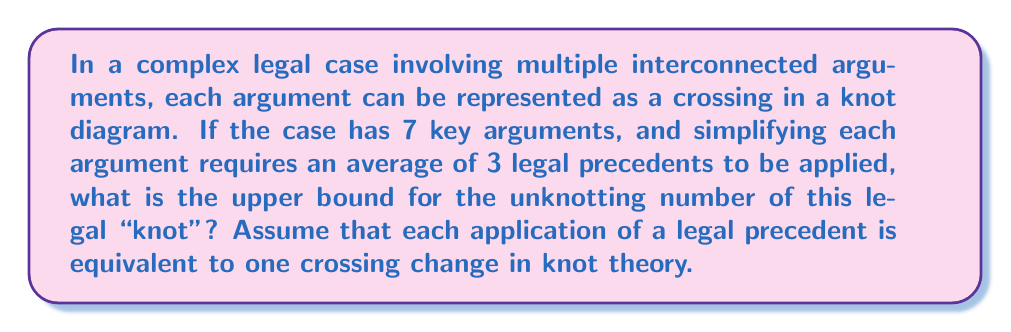Give your solution to this math problem. Let's approach this step-by-step:

1) In knot theory, the unknotting number is the minimum number of crossing changes required to transform a knot into the unknot (a simple loop).

2) In our legal analogy:
   - Each argument is represented by a crossing in the knot diagram.
   - Simplifying an argument is equivalent to changing a crossing.
   - The goal is to simplify all arguments to reach a clear, "unknotted" legal conclusion.

3) We are given:
   - Number of key arguments: 7
   - Average number of legal precedents needed to simplify each argument: 3

4) In the worst-case scenario, we might need to apply all 3 precedents to each argument to simplify it. This gives us an upper bound.

5) To calculate the upper bound:
   $$ \text{Upper bound} = \text{Number of arguments} \times \text{Average precedents per argument} $$
   $$ \text{Upper bound} = 7 \times 3 = 21 $$

6) In knot theory terms, this means our legal "knot" has an unknotting number of at most 21.

It's important to note that this is an upper bound. In practice, some arguments might be simplified with fewer precedents, or simplifying one argument might automatically simplify others, potentially reducing the actual number of steps needed.
Answer: 21 